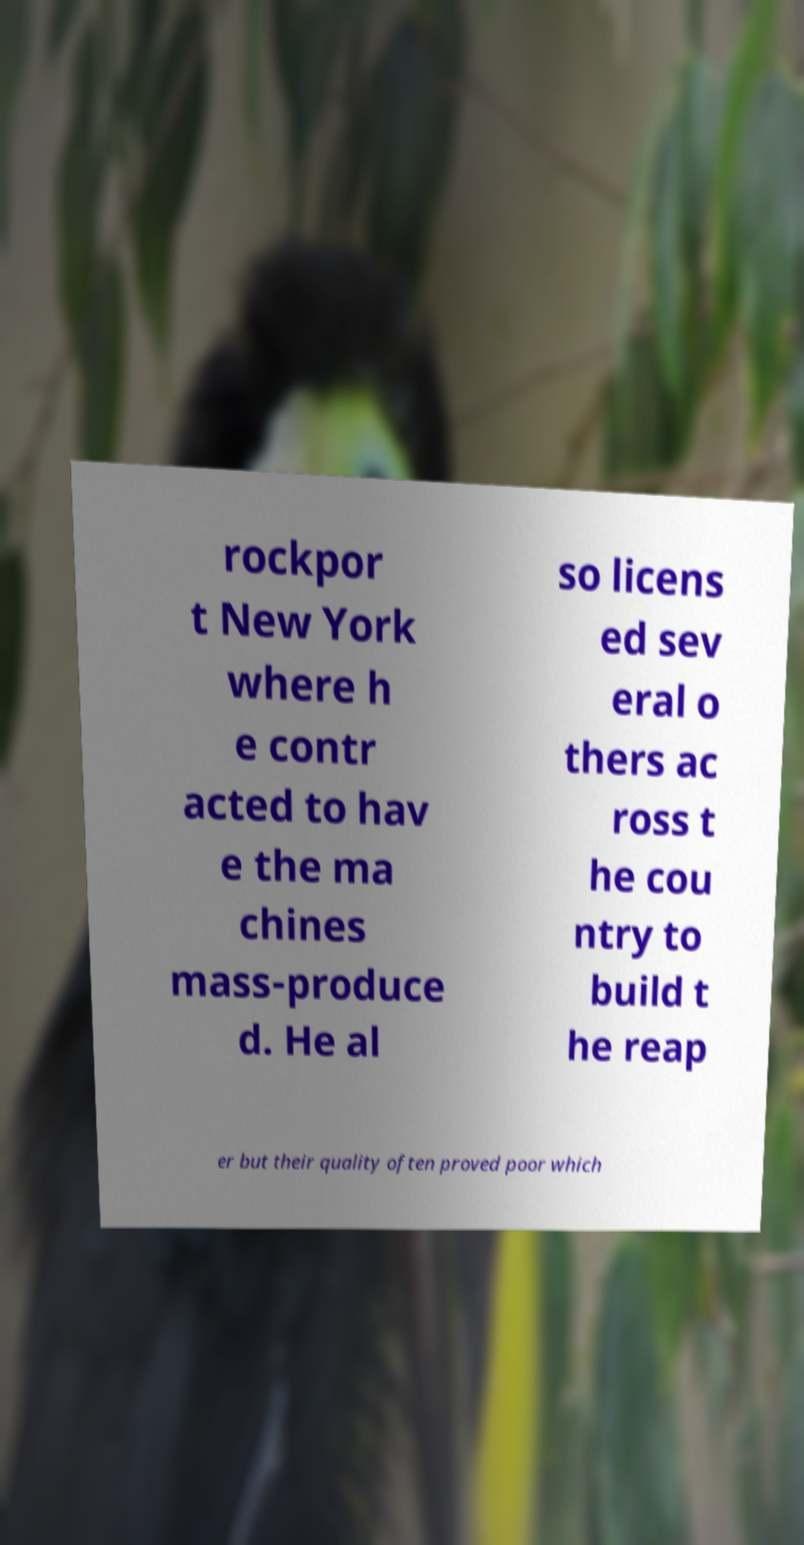I need the written content from this picture converted into text. Can you do that? rockpor t New York where h e contr acted to hav e the ma chines mass-produce d. He al so licens ed sev eral o thers ac ross t he cou ntry to build t he reap er but their quality often proved poor which 